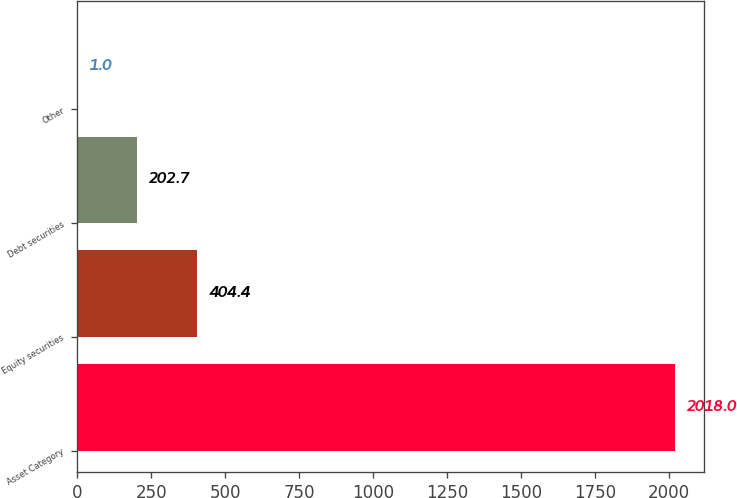Convert chart. <chart><loc_0><loc_0><loc_500><loc_500><bar_chart><fcel>Asset Category<fcel>Equity securities<fcel>Debt securities<fcel>Other<nl><fcel>2018<fcel>404.4<fcel>202.7<fcel>1<nl></chart> 